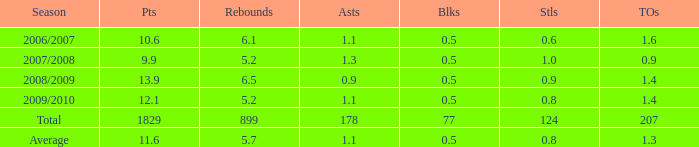What is the maximum rebounds when there are 0.9 steals and fewer than 1.4 turnovers? None. 